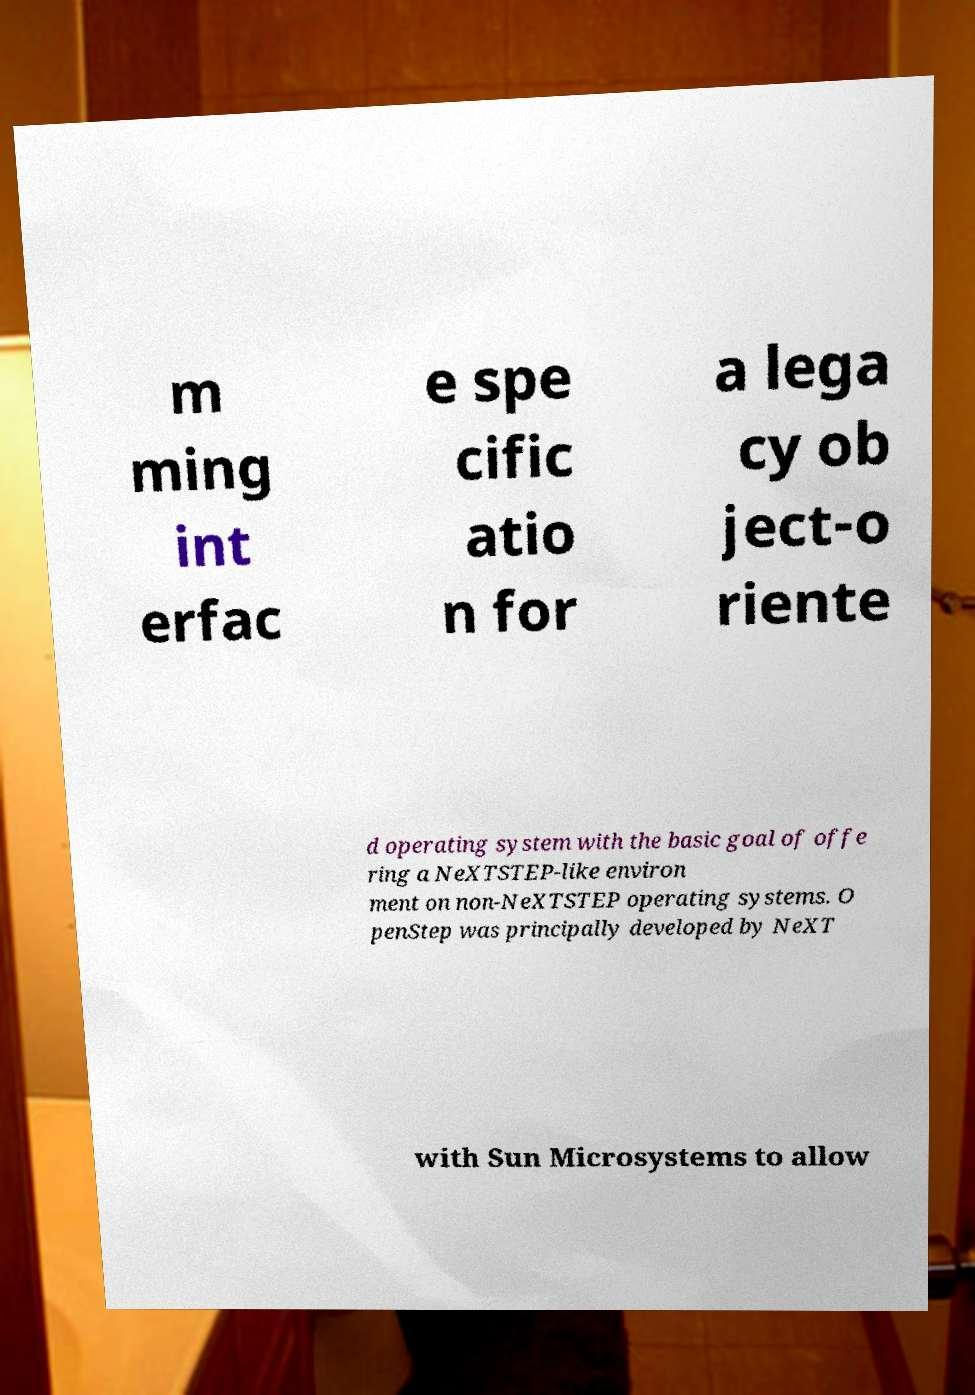Please read and relay the text visible in this image. What does it say? m ming int erfac e spe cific atio n for a lega cy ob ject-o riente d operating system with the basic goal of offe ring a NeXTSTEP-like environ ment on non-NeXTSTEP operating systems. O penStep was principally developed by NeXT with Sun Microsystems to allow 